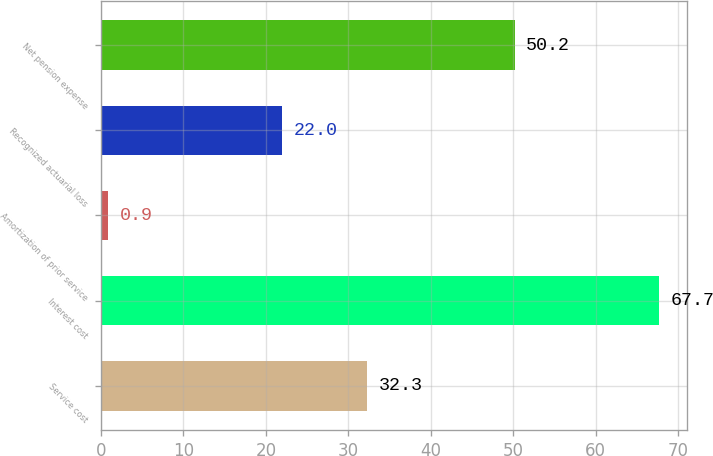<chart> <loc_0><loc_0><loc_500><loc_500><bar_chart><fcel>Service cost<fcel>Interest cost<fcel>Amortization of prior service<fcel>Recognized actuarial loss<fcel>Net pension expense<nl><fcel>32.3<fcel>67.7<fcel>0.9<fcel>22<fcel>50.2<nl></chart> 